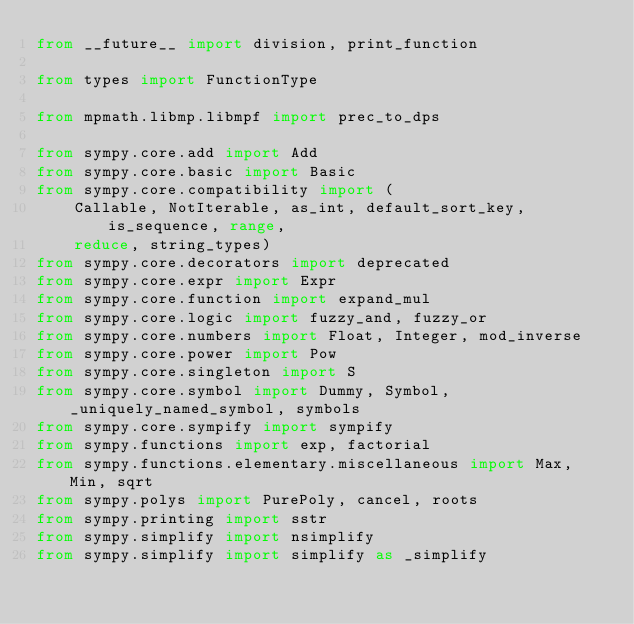Convert code to text. <code><loc_0><loc_0><loc_500><loc_500><_Python_>from __future__ import division, print_function

from types import FunctionType

from mpmath.libmp.libmpf import prec_to_dps

from sympy.core.add import Add
from sympy.core.basic import Basic
from sympy.core.compatibility import (
    Callable, NotIterable, as_int, default_sort_key, is_sequence, range,
    reduce, string_types)
from sympy.core.decorators import deprecated
from sympy.core.expr import Expr
from sympy.core.function import expand_mul
from sympy.core.logic import fuzzy_and, fuzzy_or
from sympy.core.numbers import Float, Integer, mod_inverse
from sympy.core.power import Pow
from sympy.core.singleton import S
from sympy.core.symbol import Dummy, Symbol, _uniquely_named_symbol, symbols
from sympy.core.sympify import sympify
from sympy.functions import exp, factorial
from sympy.functions.elementary.miscellaneous import Max, Min, sqrt
from sympy.polys import PurePoly, cancel, roots
from sympy.printing import sstr
from sympy.simplify import nsimplify
from sympy.simplify import simplify as _simplify</code> 